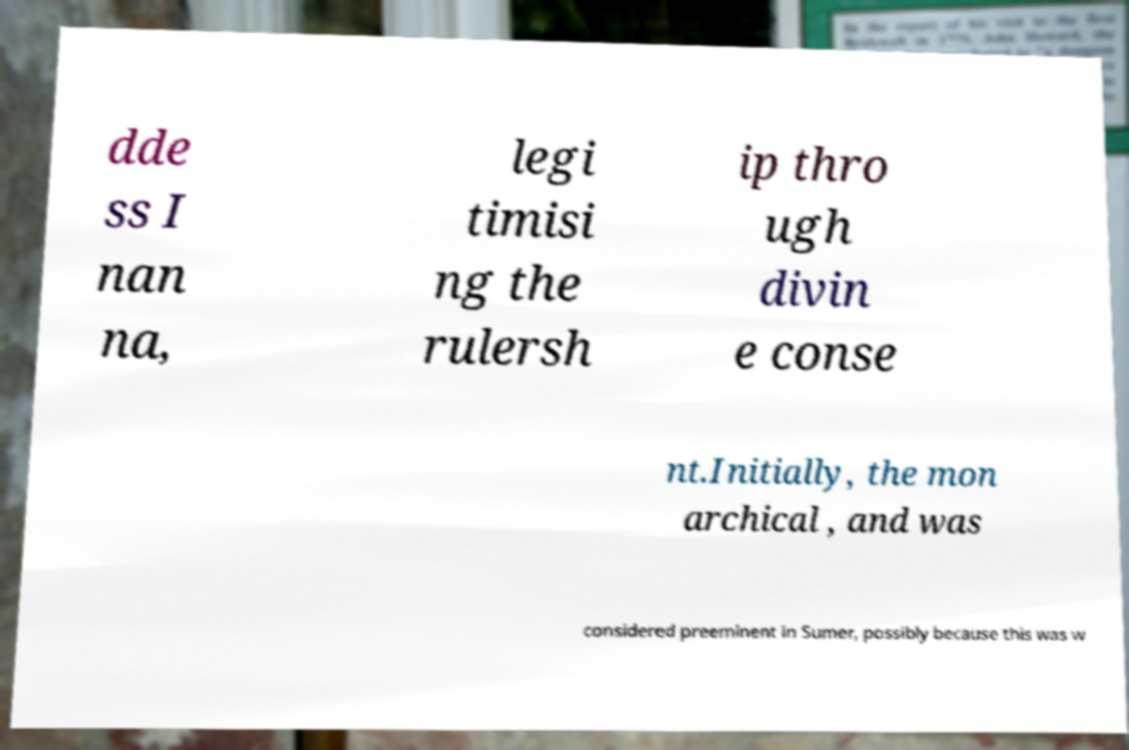Please read and relay the text visible in this image. What does it say? dde ss I nan na, legi timisi ng the rulersh ip thro ugh divin e conse nt.Initially, the mon archical , and was considered preeminent in Sumer, possibly because this was w 